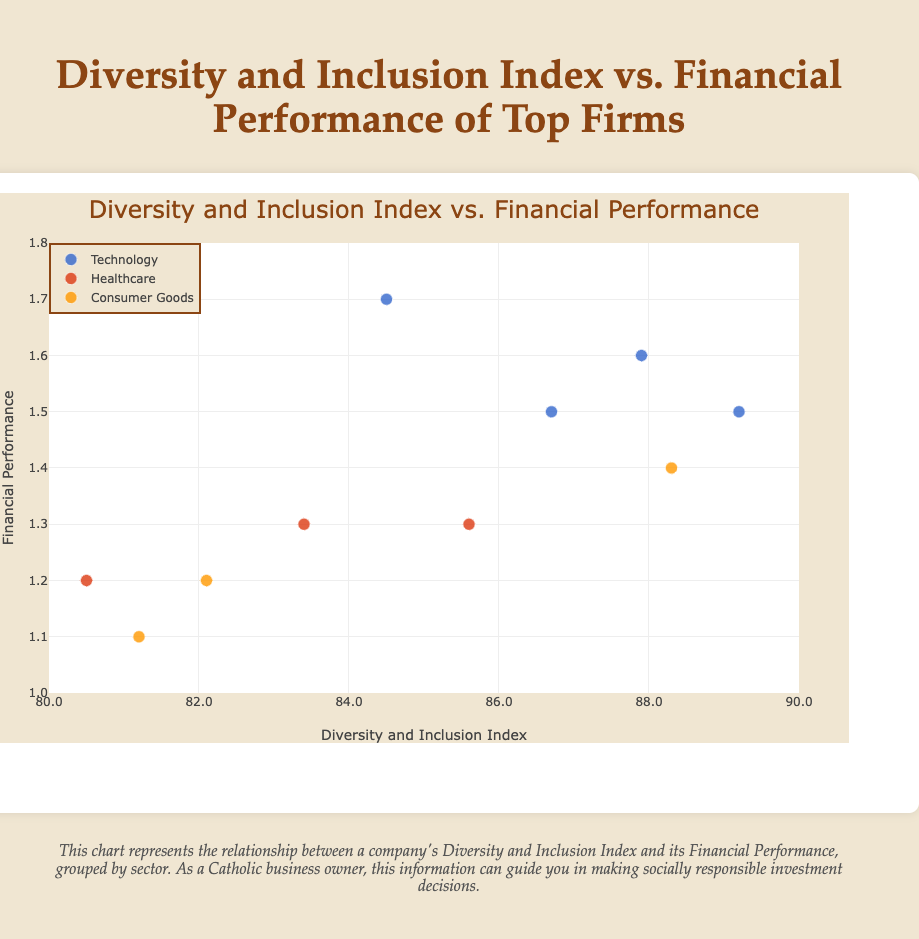What is the title of the chart? The title is typically displayed at the top of the chart. It summarizes the main point of the data visualization. In this case, it reads "Diversity and Inclusion Index vs. Financial Performance of Top Firms."
Answer: Diversity and Inclusion Index vs. Financial Performance of Top Firms What range of Diversity and Inclusion Index values is covered in the chart? The range of Diversity and Inclusion Index can be identified by looking at the x-axis scale. Here, it goes from 80 to 90.
Answer: 80 to 90 Which sector shows the highest financial performance overall? To determine this, observe the y-axis values for each sector group. The Technology sector contains data points with notably high values, especially companies like Apple and Google.
Answer: Technology How does Johnson & Johnson’s Diversity and Inclusion Index compare to Merck & Co.? Johnson & Johnson has a Diversity and Inclusion Index of 85.6 while Merck & Co. has an Index of 83.4. Therefore, Johnson & Johnson's Index is higher.
Answer: Johnson & Johnson has a higher Index Which company in the Consumer Goods sector has the highest Diversity and Inclusion Index? By filtering for the Consumer Goods sector and then finding the highest value on the x-axis, Procter & Gamble has the highest Diversity and Inclusion Index at 88.3.
Answer: Procter & Gamble Is there a visible trend between Diversity and Inclusion Index and Financial Performance within the Technology sector? Examine the scatter plot points for the Technology sector. There appears to be a positive correlation where higher Diversity and Inclusion Index values generally relate to higher Financial Performance values.
Answer: Yes, a positive trend Which company has the lowest Financial Performance in the chart? The lowest Financial Performance can be identified by looking at the lowest point on the y-axis. PepsiCo has a Financial Performance value of 1.1, which is the lowest.
Answer: PepsiCo What is the average Financial Performance of the Healthcare sector companies? Calculate by summing the Financial Performance values of Johnson & Johnson (1.3), Merck & Co. (1.3), and Pfizer (1.2), then dividing by the number of companies, which is 3. So, (1.3 + 1.3 + 1.2)/3 = 1.27.
Answer: 1.27 Which sectors are represented in the chart? Identify the sectors by observing the legend. The sectors included are Technology, Healthcare, and Consumer Goods.
Answer: Technology, Healthcare, Consumer Goods 